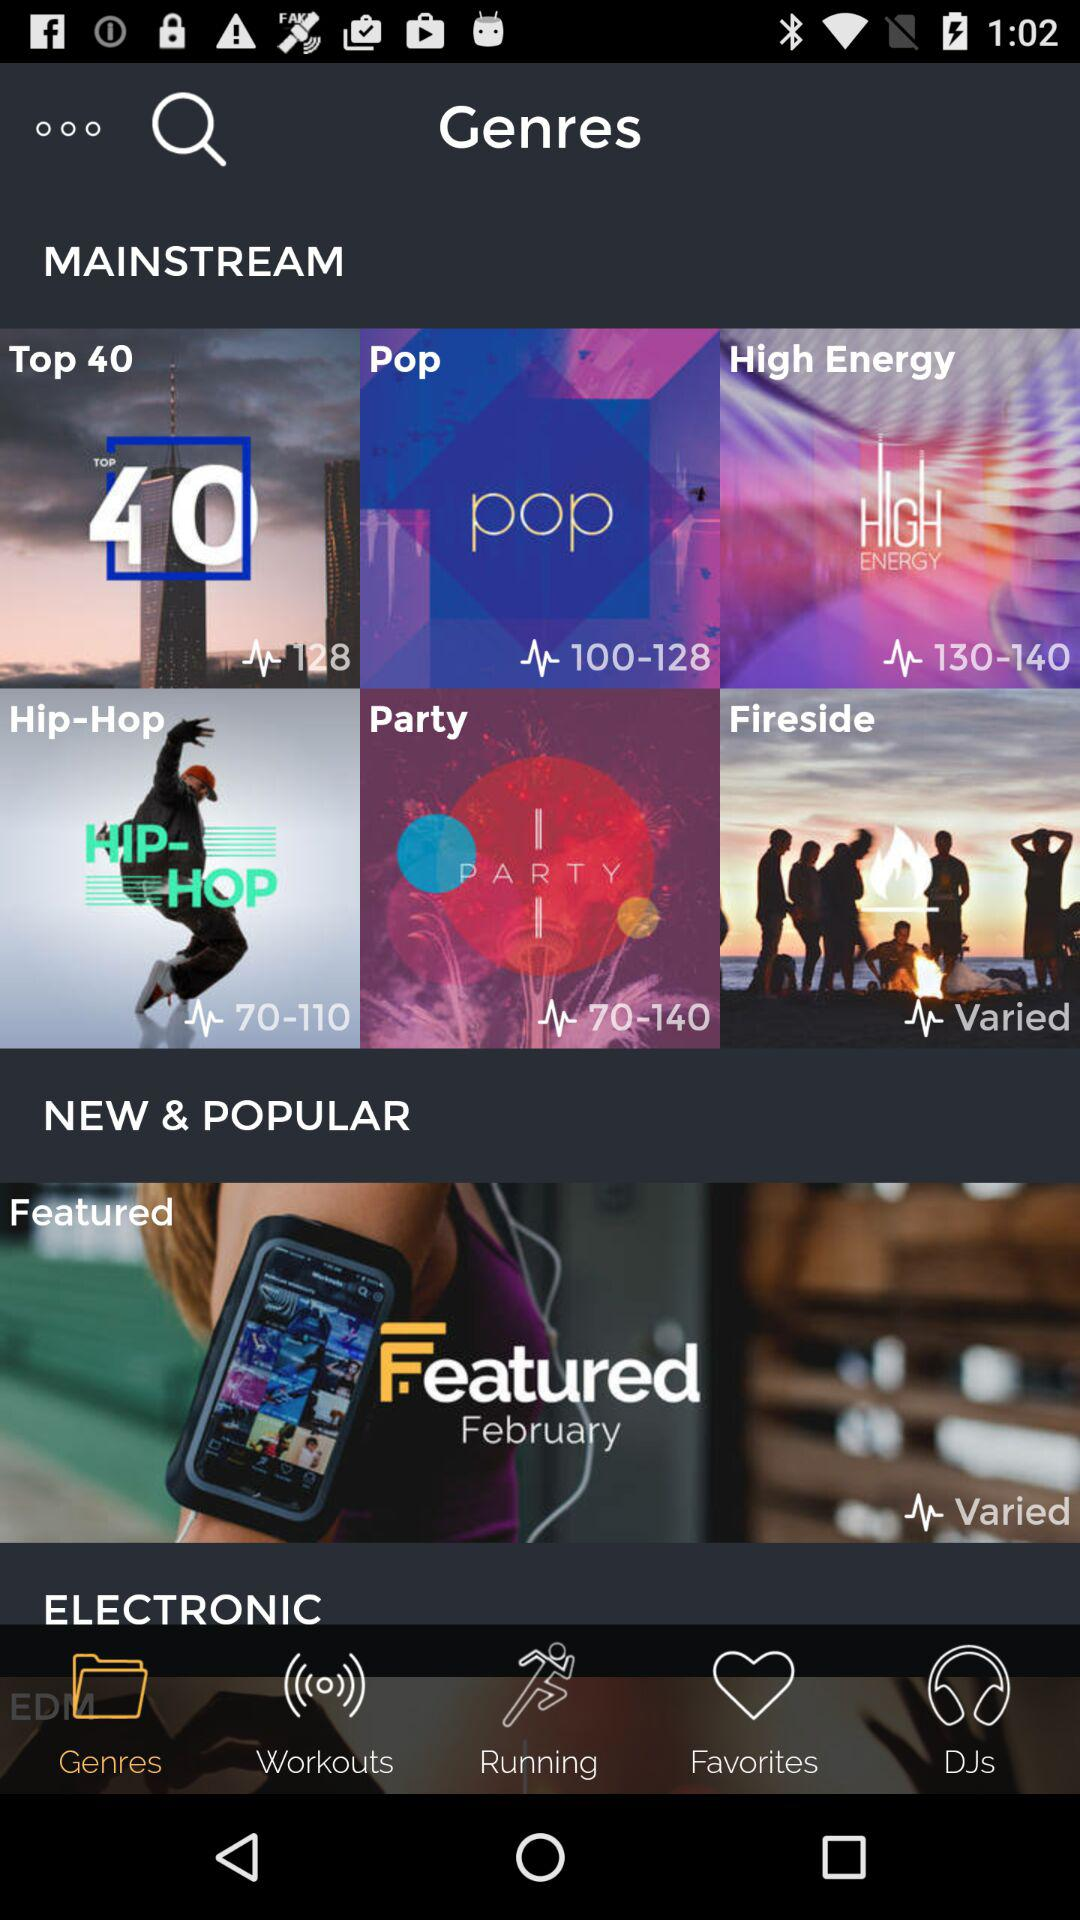Which tab is open? The open tab is "Genres". 